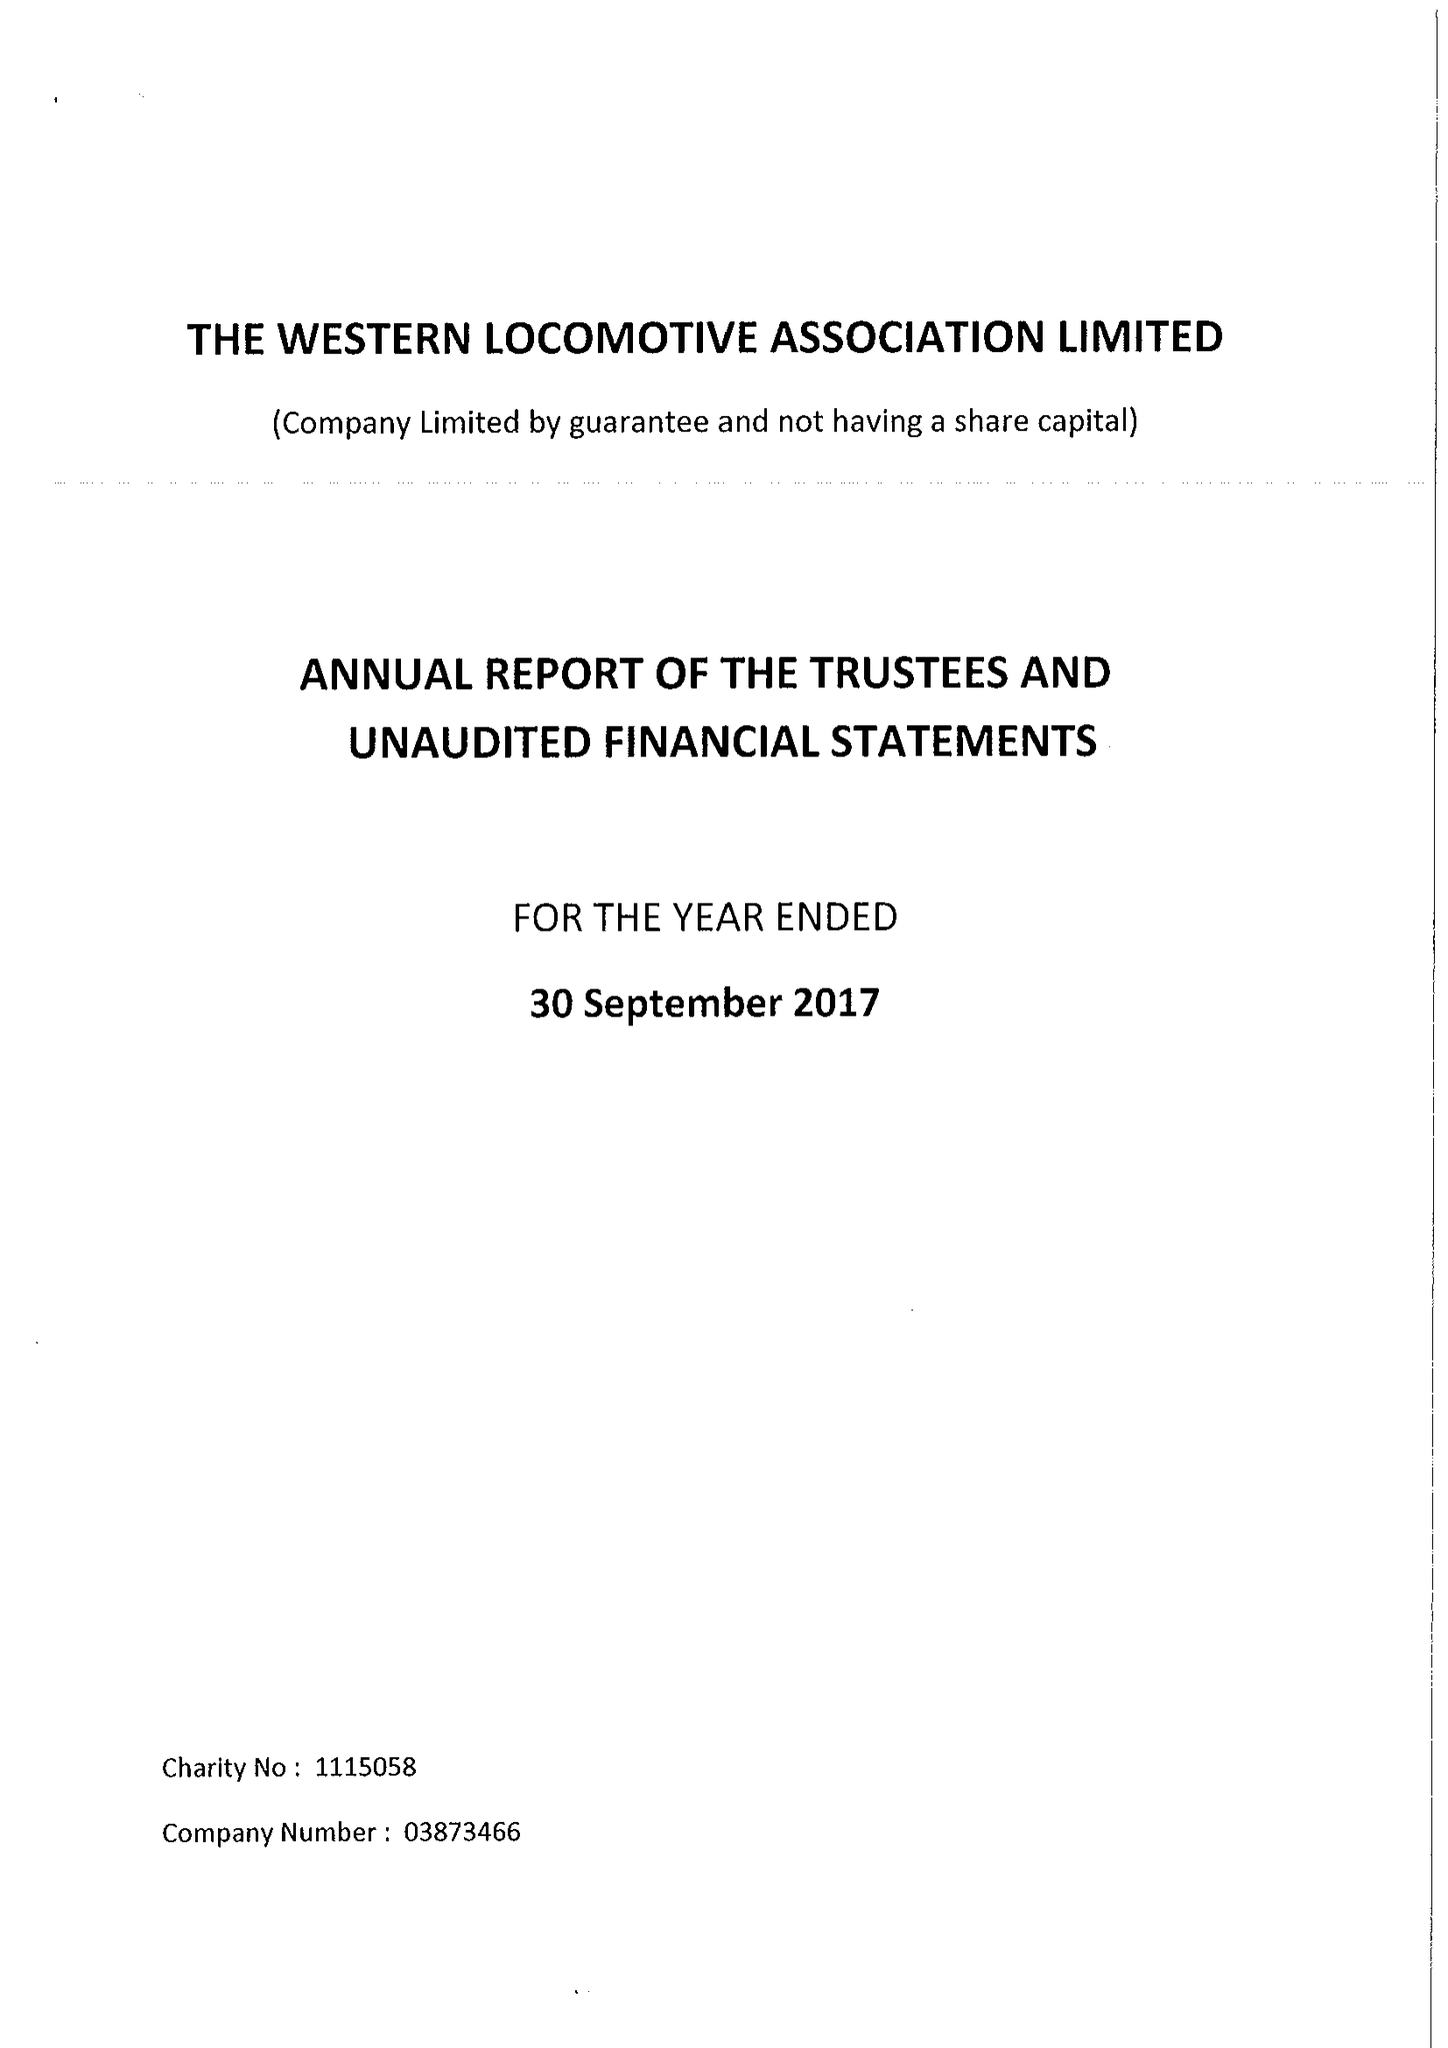What is the value for the address__postcode?
Answer the question using a single word or phrase. ST17 0BS 